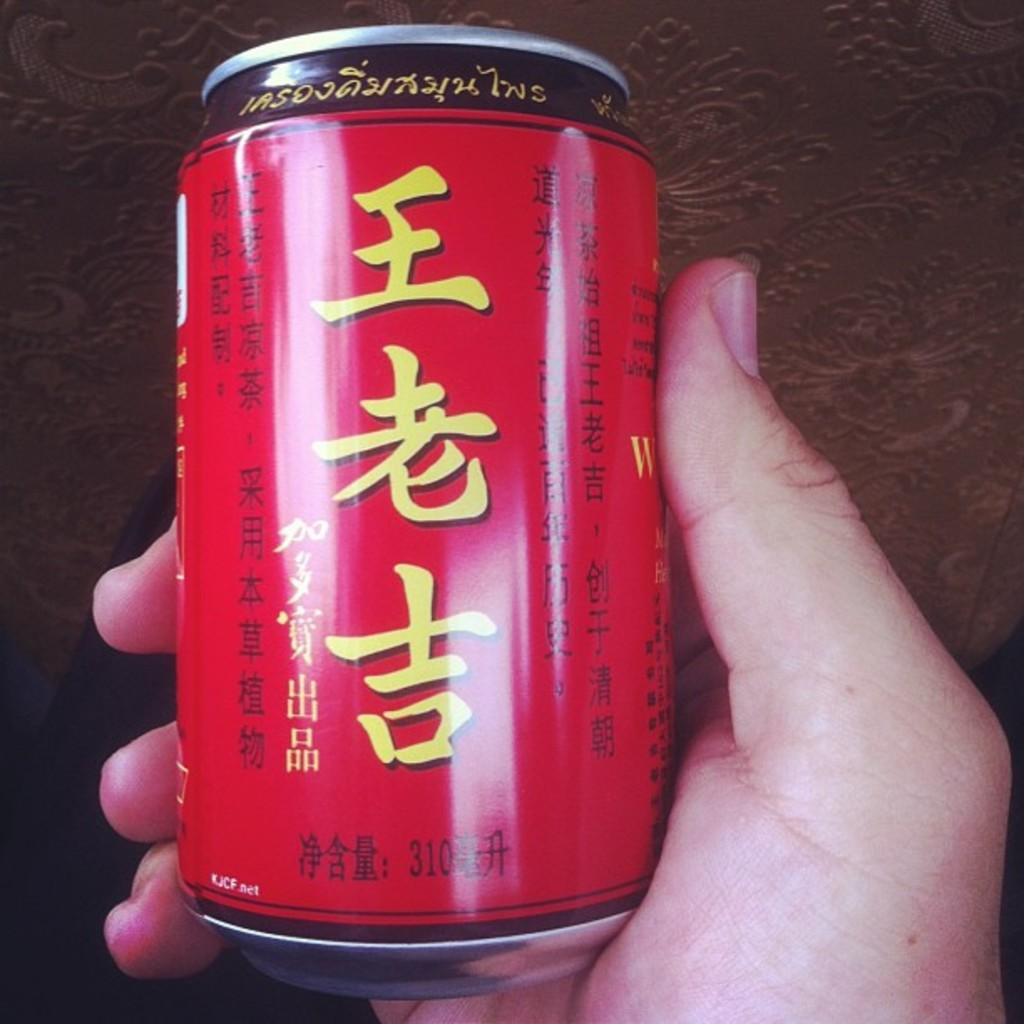Provide a one-sentence caption for the provided image. A hand is holding a red beverage can with the KJCF.net url on it. 